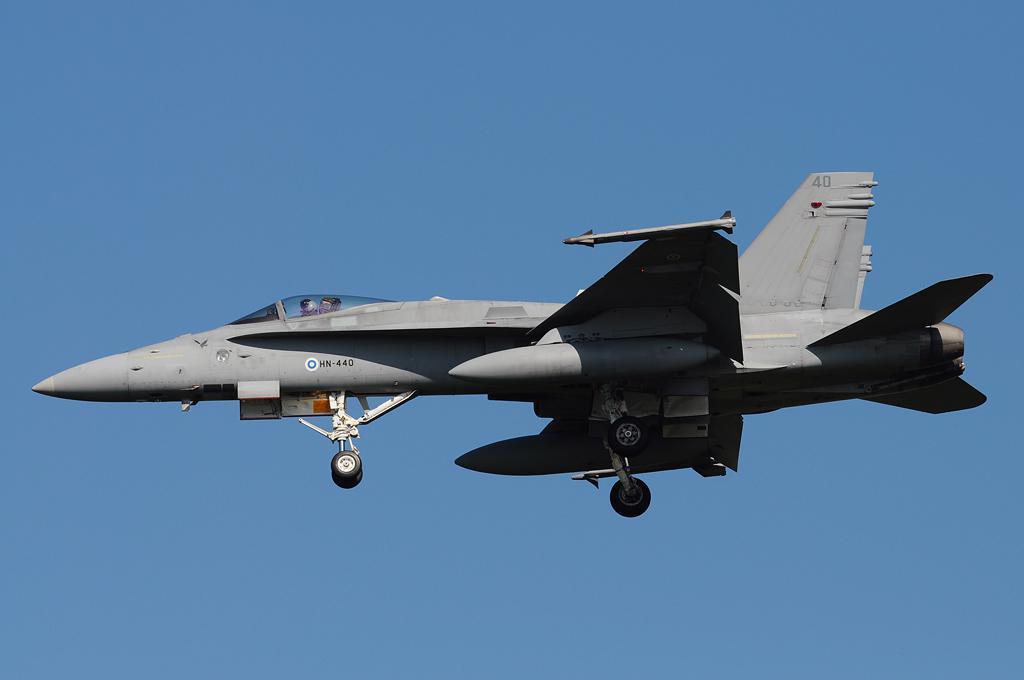How would you summarize this image in a sentence or two? In this image we can see an aircraft which is flying in the sky and there are two persons sitting in it and at the background of the image there is clear sky. 